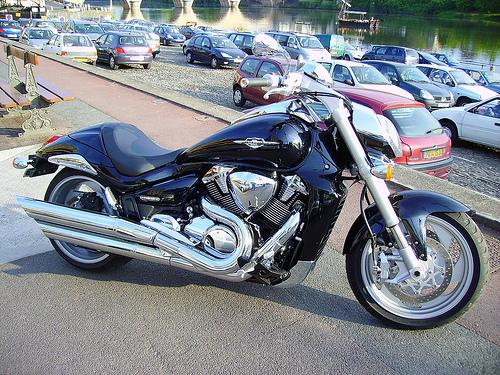Analyze the overall sentiment of the image by describing its visual elements. The image displays a calm atmosphere, with a large black motorcycle parked in a gravel lot near a body of water alongside various parked cars and a serene environment. What is the main object in the image and its attributes? The main object is a large black motorcycle with various parts such as handlebars, seat, fender, exhaust pipes, and headlight. Mention the types of vehicles found in the image. Motorcycle, cars, and a boat. How many cars are parked in the lot, and what are their colors? There are 5 cars. They are red, blue, white, violet, and black. Explain the environment that surrounds the main object and how they interact. The motorcycle is surrounded by a gravel parking lot with a bench behind it, numerous parked cars, and a body of water nearby. The motorcycle is parked along with other vehicles. Can you find the bench made of metal on the ground? No, it's not mentioned in the image. Can you locate the green handlebars on the bike? The information mentions right handlebars of the bike, but it doesn't specify their color as green. Therefore, this is a misleading instruction. Is there a small red tire on the bike? There are mentions of front and back tires of the bike, black color tire, and edge of a wheel, but no mention of a small red tire, making this statement misleading. Can you find the orange car parked in the parking area? There is no mention of an orange car in the given information. There are red, blue, white, and violet cars mentioned, but no orange car. Where is the pink boat floating in the water? There is a mention of a boat in the water, but it doesn't give any color information, so assuming it's pink is misleading. 